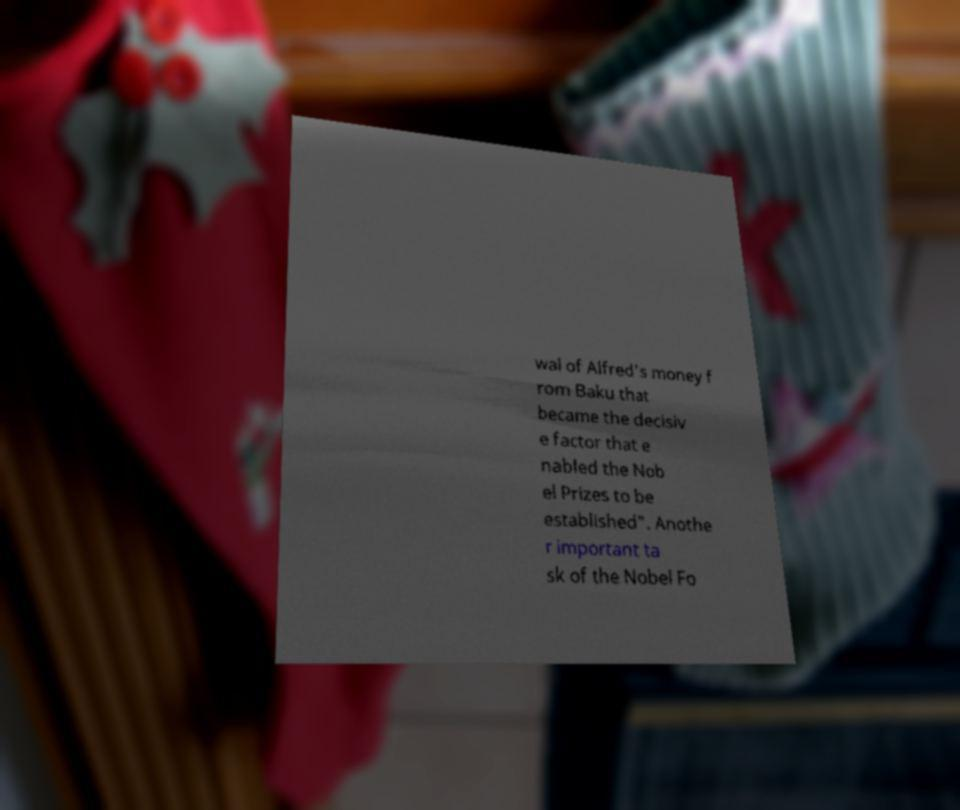For documentation purposes, I need the text within this image transcribed. Could you provide that? wal of Alfred's money f rom Baku that became the decisiv e factor that e nabled the Nob el Prizes to be established". Anothe r important ta sk of the Nobel Fo 